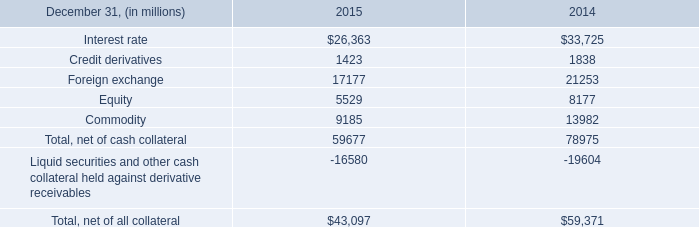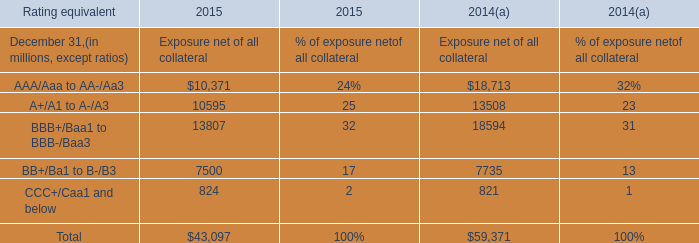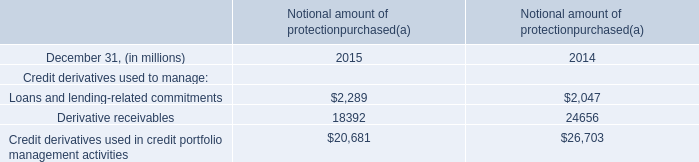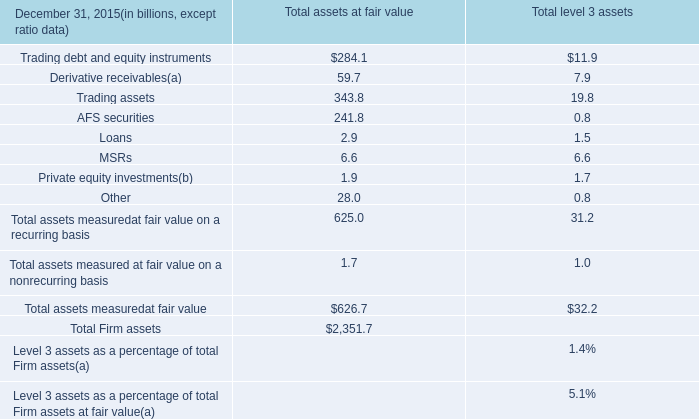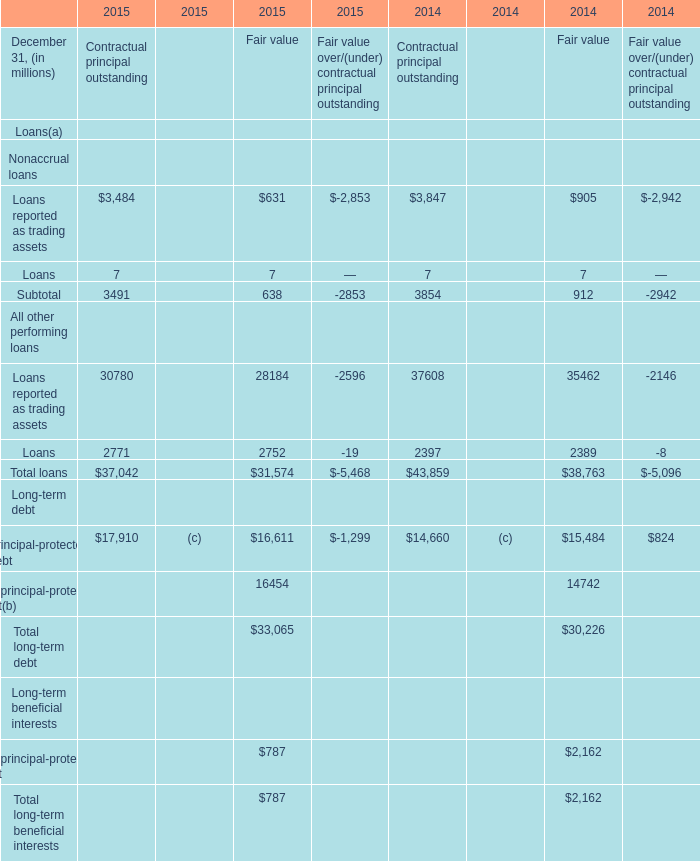What is the average value of BB+/Ba1 to B-/B3 of Exposure net of all collateral in Table 1 and Derivative receivables in Table 2 in 2014? (in million) 
Computations: ((7735 + 24656) / 2)
Answer: 16195.5. 